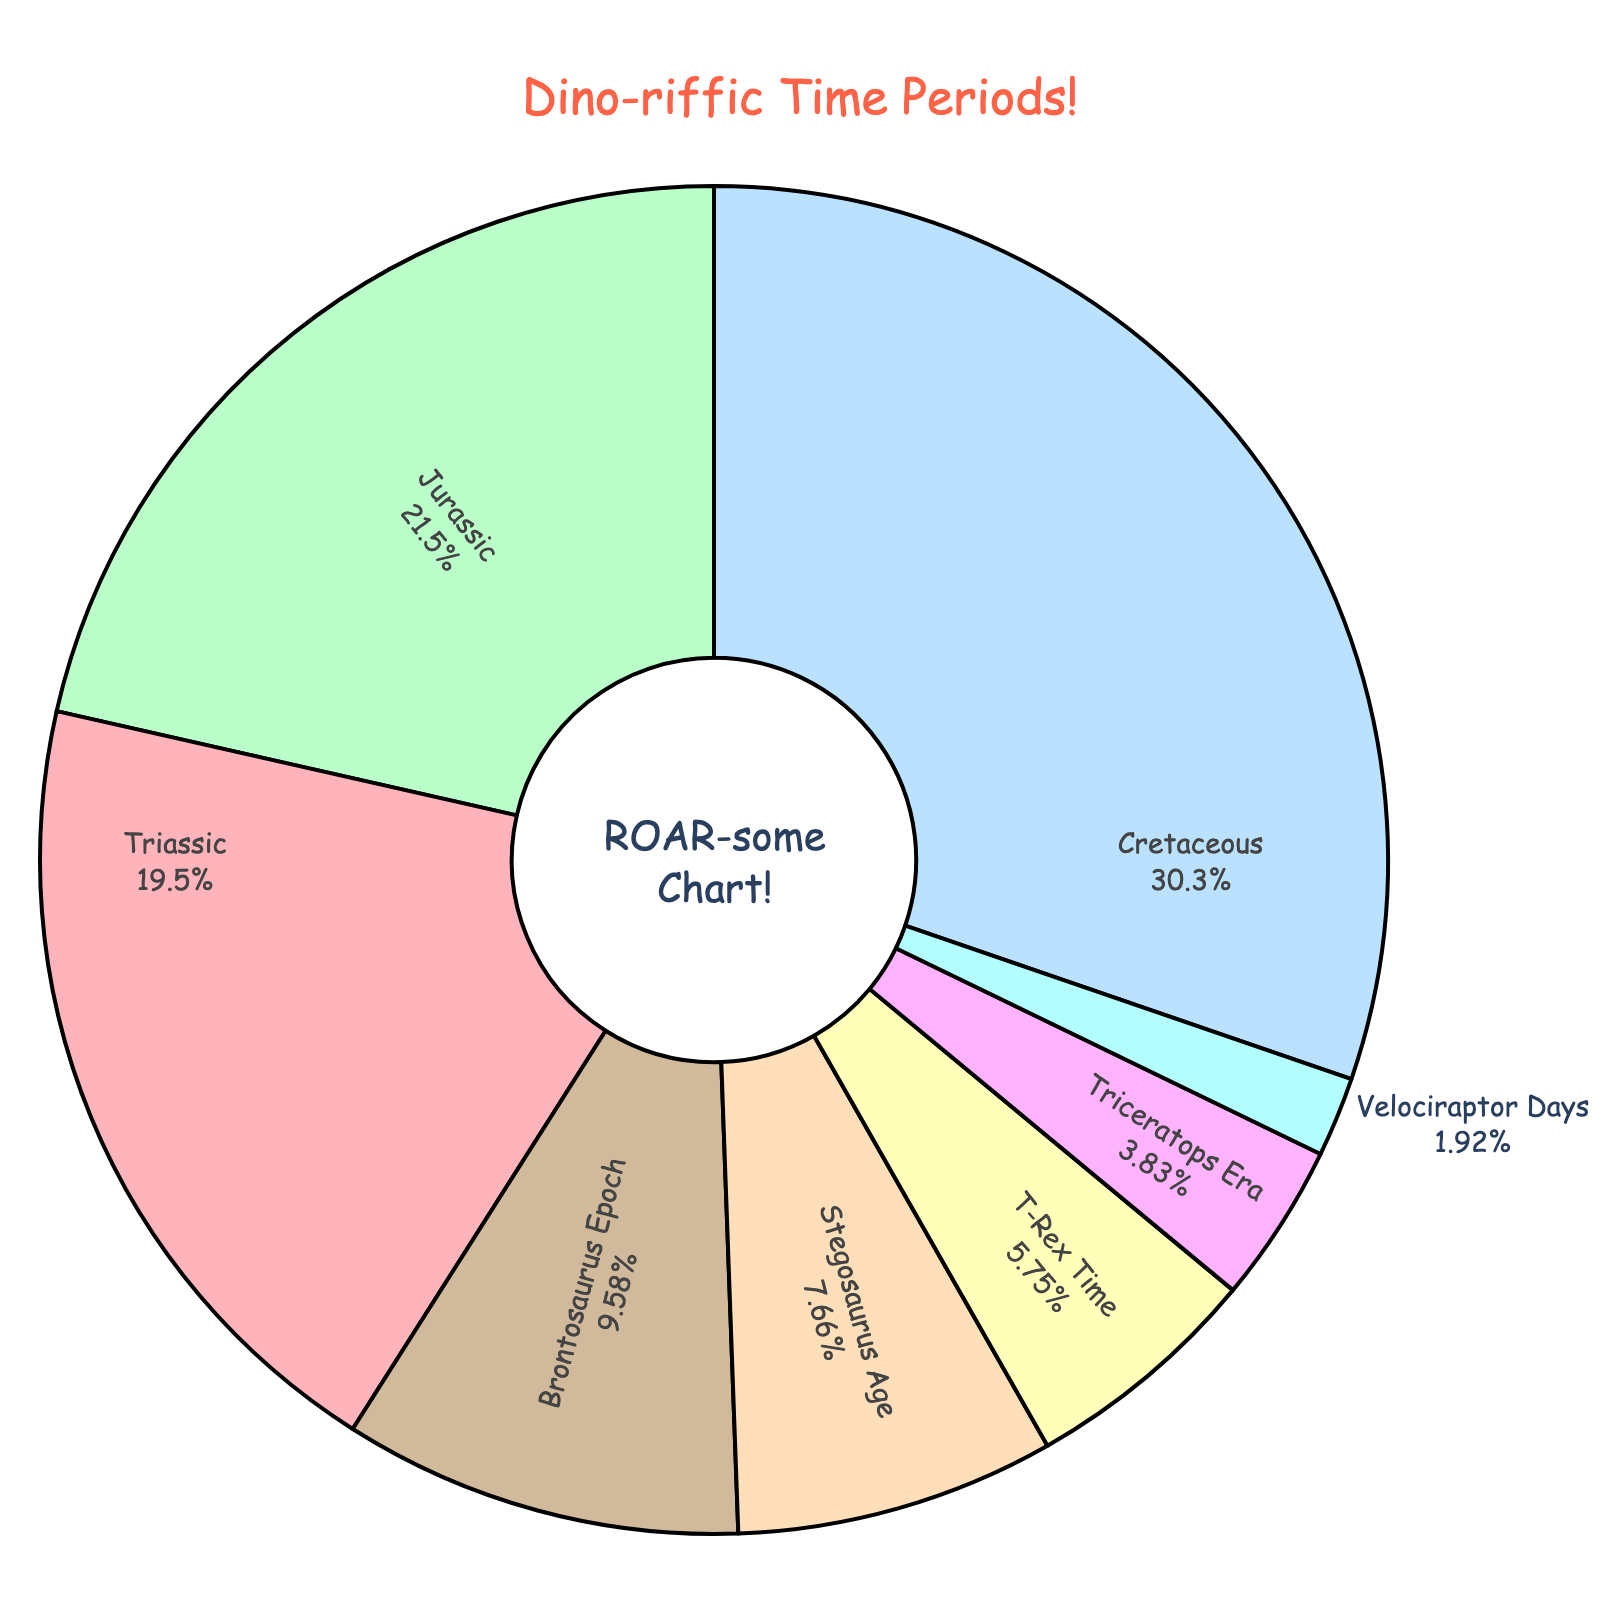What's the longest time period in the figure? To find the longest time period, identify the section with the largest duration. The Cretaceous period has the longest duration of 79 million years.
Answer: Cretaceous Which period has the shortest duration? Look for the section with the smallest duration. The Velociraptor Days period has the shortest duration of 5 million years.
Answer: Velociraptor Days How many years longer is the Cretaceous period than the Triassic period? Subtract the duration of the Triassic period (51 million years) from the Cretaceous period (79 million years). 79 - 51 = 28.
Answer: 28 Which two periods together make up 15 million years? Look for two periods that add up to 15 million years. The periods are Velociraptor Days (5 million years) and Triceratops Era (10 million years). 5 + 10 = 15.
Answer: Velociraptor Days, Triceratops Era What percentage of the total time does the Jurassic period represent? The percentage is calculated by dividing the duration of the Jurassic period (56 million years) by the total duration and multiplying by 100. Total duration: 251 years. (56 / 251) * 100 ≈ 22.31%.
Answer: 22.31% Which three periods have a combined duration equal to the Cretaceous period? Find three periods whose combined durations equal the Cretaceous period (79 million years). The periods are Stegosaurus Age (20 million years), Triceratops Era (10 million years), and Brontosaurus Epoch (25 million years), adding to 55. None combine exactly to 79.
Answer: Not possible If you combined the Triassic and Jurassic periods, would their total be longer or shorter than the Cretaceous period? Add the durations of the Triassic and Jurassic periods: 51 + 56 = 107. Compare it to the Cretaceous period (79). 107 is longer than 79.
Answer: Longer What is the total duration of the Triassic, Jurassic, and Cretaceous periods together? Add the durations of these three periods: 51 (Triassic), 56 (Jurassic), and 79 (Cretaceous). 51 + 56 + 79 = 186.
Answer: 186 How many times longer is the Cretaceous period compared to the Velociraptor Days? Divide the duration of the Cretaceous period (79 million years) by the duration of the Velociraptor Days period (5 million years). 79 / 5 = 15.8.
Answer: 15.8 What's the difference in duration between the Stegosaurus Age and T-Rex Time? Subtract the duration of T-Rex Time (15 million years) from Stegosaurus Age (20 million years). 20 - 15 = 5.
Answer: 5 